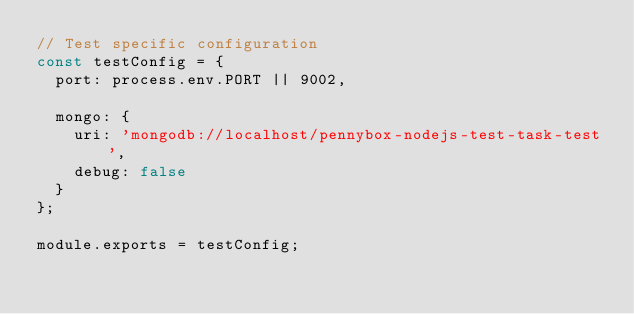Convert code to text. <code><loc_0><loc_0><loc_500><loc_500><_JavaScript_>// Test specific configuration
const testConfig = {
  port: process.env.PORT || 9002,

  mongo: {
    uri: 'mongodb://localhost/pennybox-nodejs-test-task-test',
    debug: false
  }
};

module.exports = testConfig;
</code> 